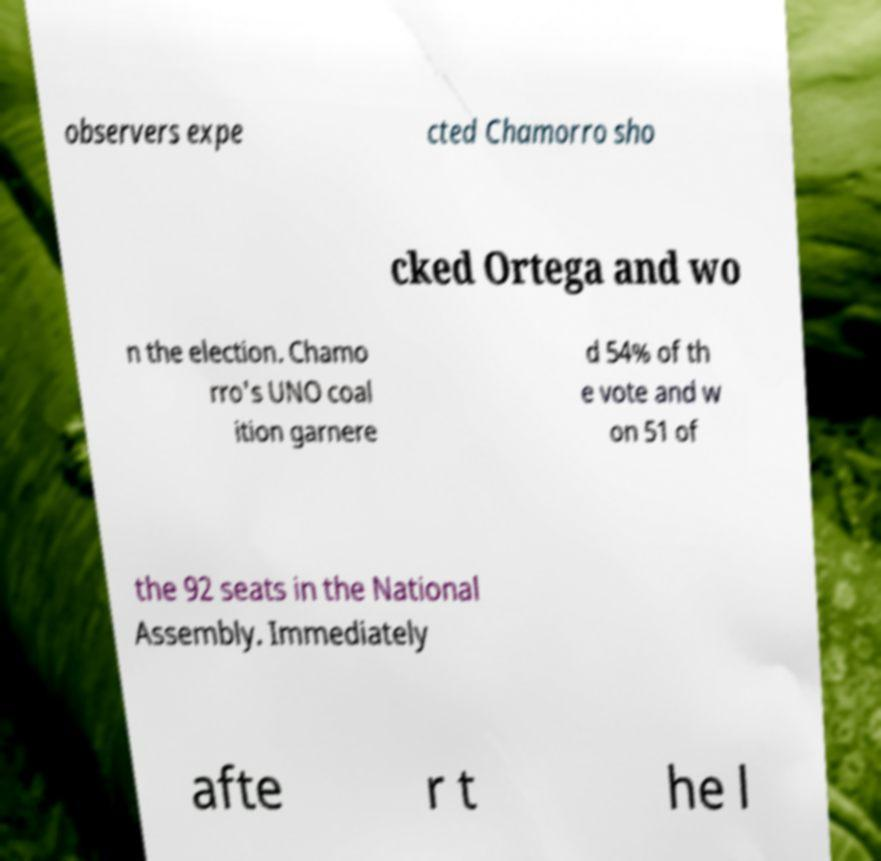I need the written content from this picture converted into text. Can you do that? observers expe cted Chamorro sho cked Ortega and wo n the election. Chamo rro's UNO coal ition garnere d 54% of th e vote and w on 51 of the 92 seats in the National Assembly. Immediately afte r t he l 